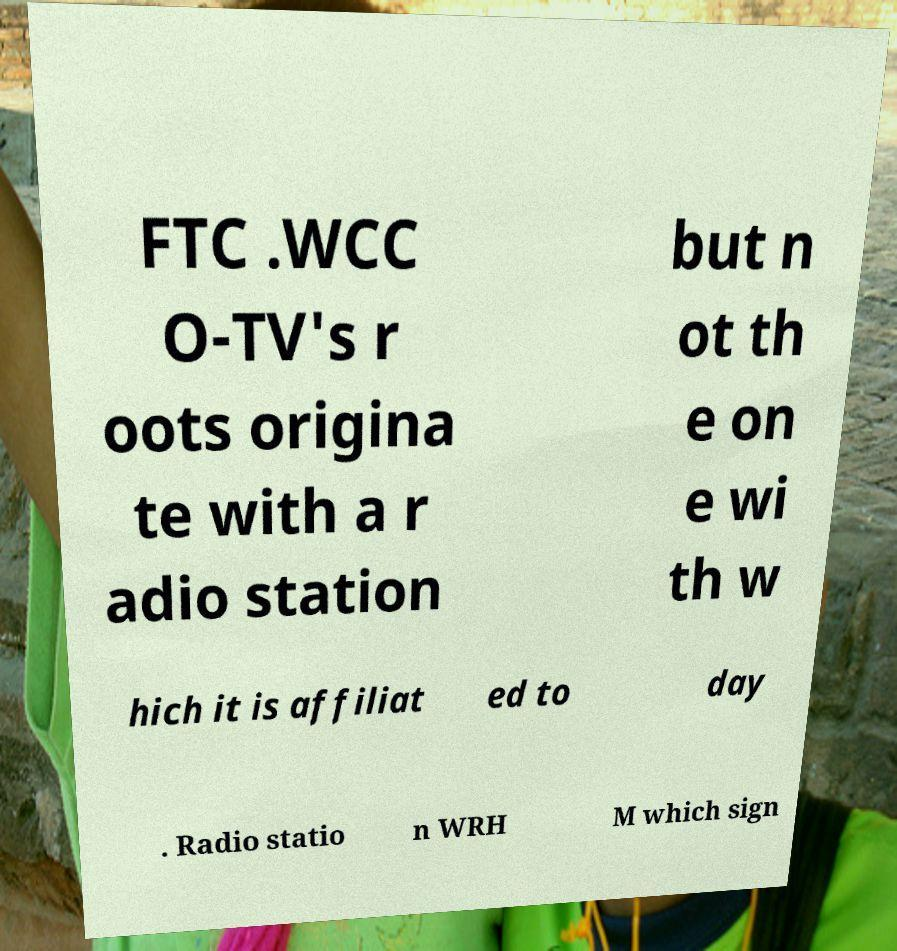What messages or text are displayed in this image? I need them in a readable, typed format. FTC .WCC O-TV's r oots origina te with a r adio station but n ot th e on e wi th w hich it is affiliat ed to day . Radio statio n WRH M which sign 